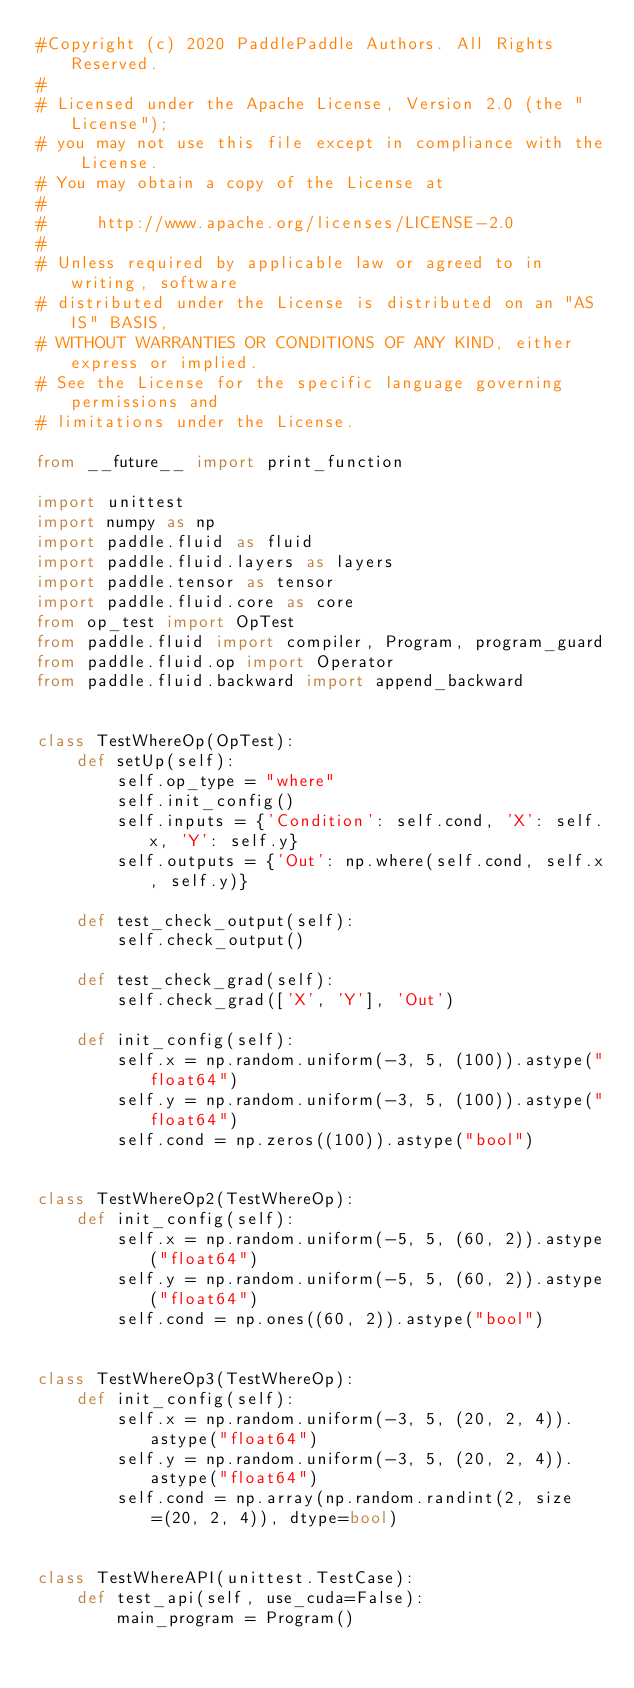Convert code to text. <code><loc_0><loc_0><loc_500><loc_500><_Python_>#Copyright (c) 2020 PaddlePaddle Authors. All Rights Reserved.
#
# Licensed under the Apache License, Version 2.0 (the "License");
# you may not use this file except in compliance with the License.
# You may obtain a copy of the License at
#
#     http://www.apache.org/licenses/LICENSE-2.0
#
# Unless required by applicable law or agreed to in writing, software
# distributed under the License is distributed on an "AS IS" BASIS,
# WITHOUT WARRANTIES OR CONDITIONS OF ANY KIND, either express or implied.
# See the License for the specific language governing permissions and
# limitations under the License.

from __future__ import print_function

import unittest
import numpy as np
import paddle.fluid as fluid
import paddle.fluid.layers as layers
import paddle.tensor as tensor
import paddle.fluid.core as core
from op_test import OpTest
from paddle.fluid import compiler, Program, program_guard
from paddle.fluid.op import Operator
from paddle.fluid.backward import append_backward


class TestWhereOp(OpTest):
    def setUp(self):
        self.op_type = "where"
        self.init_config()
        self.inputs = {'Condition': self.cond, 'X': self.x, 'Y': self.y}
        self.outputs = {'Out': np.where(self.cond, self.x, self.y)}

    def test_check_output(self):
        self.check_output()

    def test_check_grad(self):
        self.check_grad(['X', 'Y'], 'Out')

    def init_config(self):
        self.x = np.random.uniform(-3, 5, (100)).astype("float64")
        self.y = np.random.uniform(-3, 5, (100)).astype("float64")
        self.cond = np.zeros((100)).astype("bool")


class TestWhereOp2(TestWhereOp):
    def init_config(self):
        self.x = np.random.uniform(-5, 5, (60, 2)).astype("float64")
        self.y = np.random.uniform(-5, 5, (60, 2)).astype("float64")
        self.cond = np.ones((60, 2)).astype("bool")


class TestWhereOp3(TestWhereOp):
    def init_config(self):
        self.x = np.random.uniform(-3, 5, (20, 2, 4)).astype("float64")
        self.y = np.random.uniform(-3, 5, (20, 2, 4)).astype("float64")
        self.cond = np.array(np.random.randint(2, size=(20, 2, 4)), dtype=bool)


class TestWhereAPI(unittest.TestCase):
    def test_api(self, use_cuda=False):
        main_program = Program()</code> 